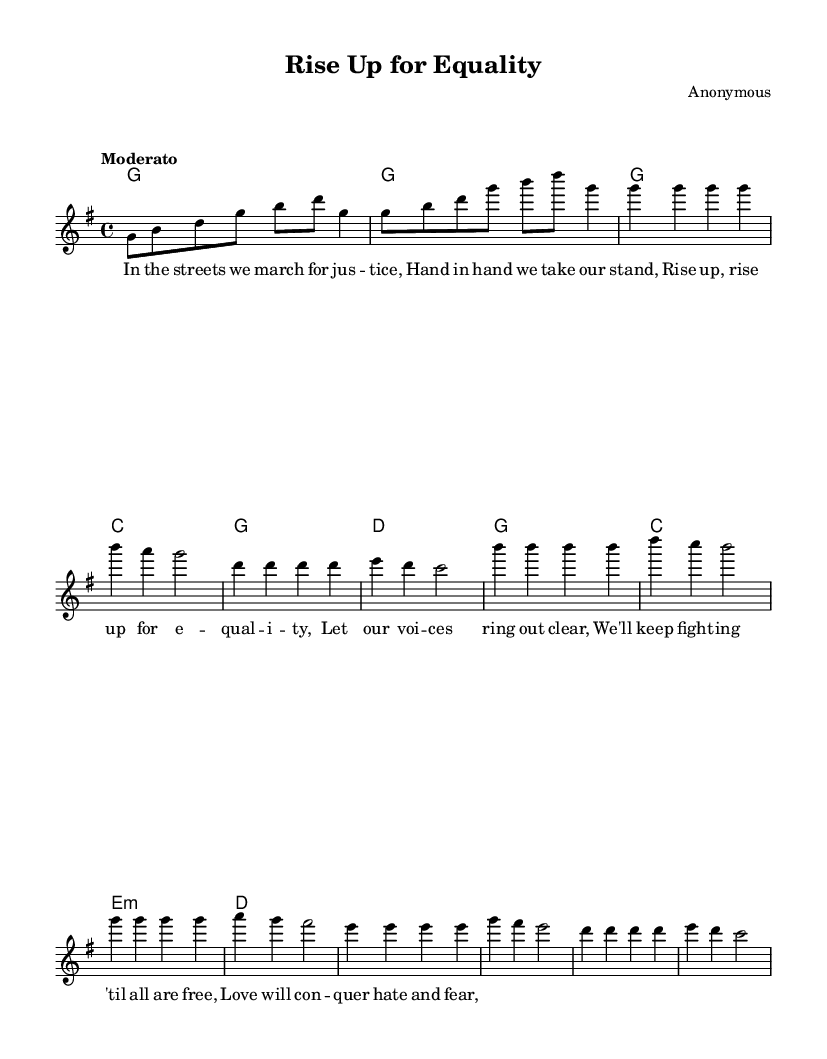What is the key signature of this music? The key signature is G major, which has one sharp (F#). This can be identified at the beginning of the staff where the sharp indicates the key signature.
Answer: G major What is the time signature of this music? The time signature is 4/4, which can be found at the beginning of the staff next to the key signature. It indicates that there are four beats in each measure and a quarter note gets one beat.
Answer: 4/4 What is the tempo marking of the piece? The tempo marking is "Moderato," which appears at the beginning of the score, indicating a moderate speed for the rhythm of the piece.
Answer: Moderato How many measures are in the verse section? The verse consists of 4 measures, which can be counted by looking at the vertical lines on the staff that separate each measure.
Answer: 4 What is the highest note in the melody? The highest note in the melody is B, which can be spotted within the melody line where it appears on the staff at its peak.
Answer: B What is the main theme expressed in the lyrics of the chorus? The lyrics of the chorus express a theme of equality and resistance against hate, as indicated by phrases like "Rise up for equality" and "Love will conquer hate and fear." This reflects the social justice themes present in the song.
Answer: Equality What type of harmony is used in the chorus? The harmony in the chorus features a combination of triadic chords and a minor chord, which combines both consonant and somewhat dissonant sounds, typical of religious music that conveys deep emotion and struggle.
Answer: Triadic harmony 